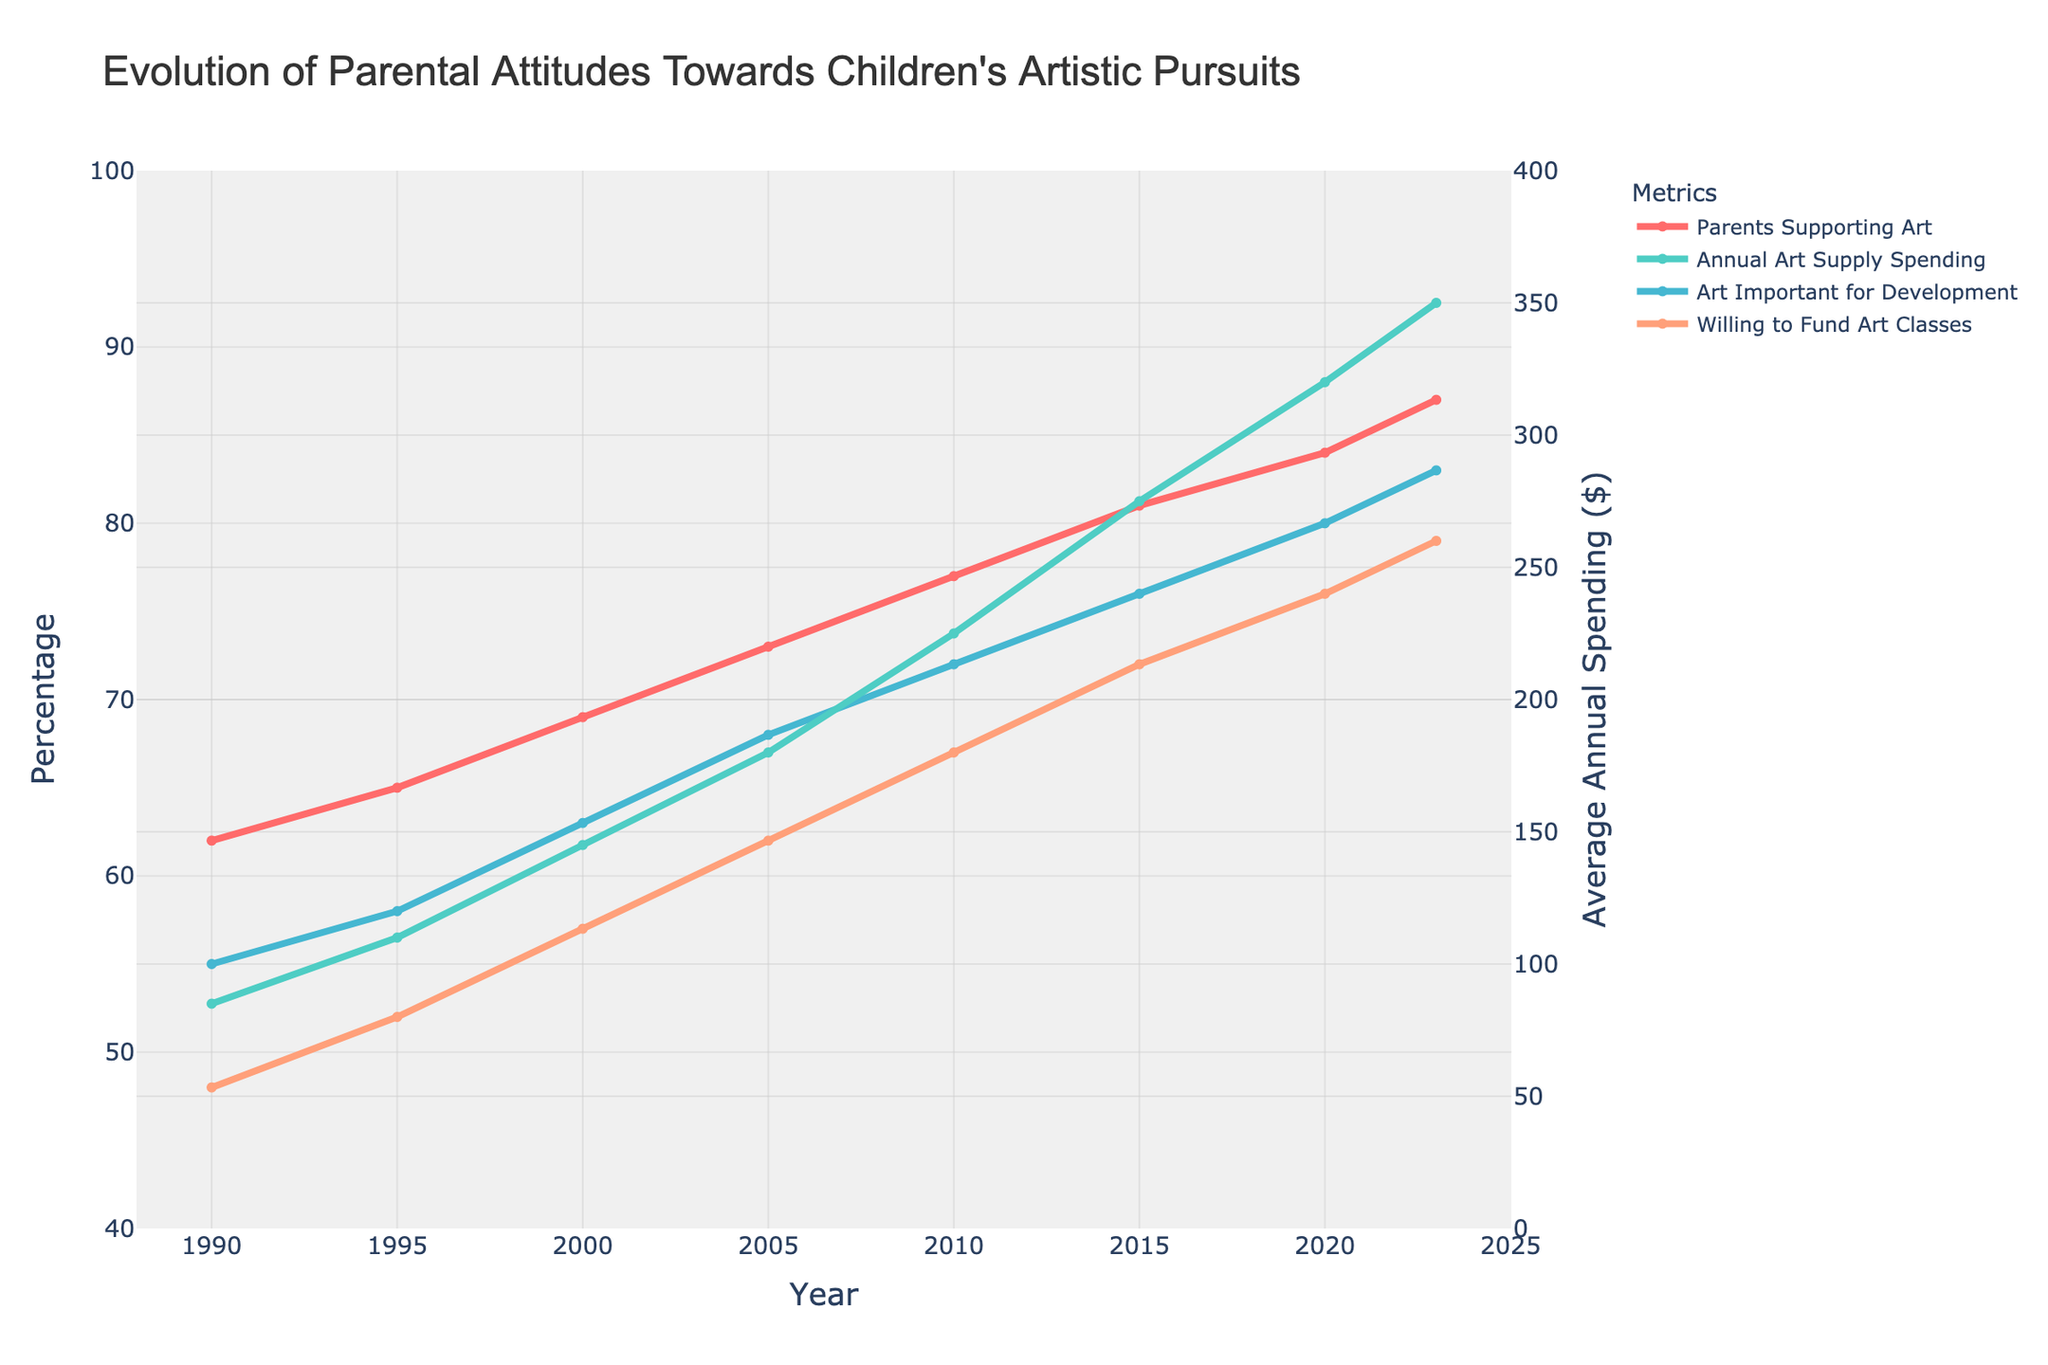what was the average annual spending on art supplies in 2000 and how much common is the average annual spending on art supply in 2023? In the figure, the line representing the "Annual Art Supply Spending" in 2000 intersects the y-axis at 145$. In 2023, it intersects at 350$. So the increment is 350 - 145 = 205$.
Answer: 205$ Did the percentage of parents supporting artistic pursuits increase more from 1995 to 2000 or from 2015 to 2020? From the figure, the "Parents Supporting Art" line shows an increase from 65% in 1995 to 69% in 2000, which is a 4% increase. From 2015 to 2020, it increased from 81% to 84%, a 3% increase. Thus, the increase was greater from 1995 to 2000.
Answer: 1995 to 2000 Which year saw the highest average annual spending on art supplies? From the figure, the highest point on the "Annual Art Supply Spending" line corresponds to the year 2023, with an amount of 350$.
Answer: 2023 By how much did the percentage of parents viewing art as important for child development change between 1990 and 2010? The "Art Important for Development" line shows an increase from 55% in 1990 to 72% in 2010. To find the change, subtract the smaller percentage from the larger one: 72% - 55% = 17%.
Answer: 17% What's the trend of parents willing to fund art classes from 1990 to 2023? Referencing the "Willing to Fund Art Classes" line, it consistently rises from 48% in 1990 to 79% in 2023. This shows a clear increasing trend over time.
Answer: Increasing trend How much did the average annual spending on art supplies increase from 2010 to 2023? According to the "Annual Art Supply Spending" line, the values increase from 225$ in 2010 to 350$ in 2023. The difference is 350$ - 225$ = 125$.
Answer: 125$ When did the average annual spending on art supplies cross the 200$ mark? Looking at the "Annual Art Supply Spending" line, the spending value first exceeds 200$ between 2005 and 2010; in 2010, it is 225$.
Answer: 2010 Is there any year where the percentage of parents viewing art as important for child development is equal to the percentage of parents willing to fund art classes? From the figure, there is no year where these two lines intersect or match exactly.
Answer: No What is the relationship between the percentage of parents supporting artistic pursuits and the average annual spending on art supplies over time? To determine the relationship, observe both the "Parents Supporting Art" line and the "Annual Art Supply Spending" line. Both show a pronounced upward trend over the years, indicating a positive correlation between the support for artistic pursuits and spending.
Answer: Positive correlation 